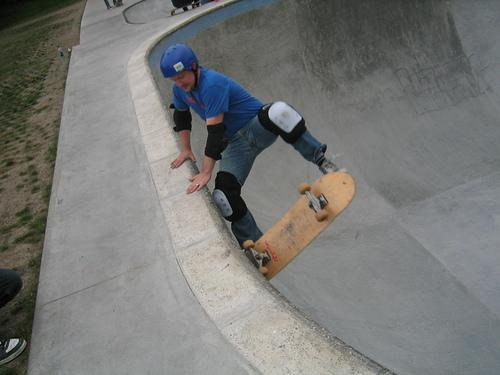What is the area the man is skating in usually called?

Choices:
A) arena
B) bowl
C) deck
D) zoo bowl 